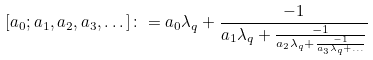Convert formula to latex. <formula><loc_0><loc_0><loc_500><loc_500>[ a _ { 0 } ; a _ { 1 } , a _ { 2 } , a _ { 3 } , \dots ] \colon = a _ { 0 } \lambda _ { q } + \frac { - 1 } { a _ { 1 } \lambda _ { q } + \frac { - 1 } { a _ { 2 } \lambda _ { q } + \frac { - 1 } { a _ { 3 } \lambda _ { q } + \dots } } }</formula> 